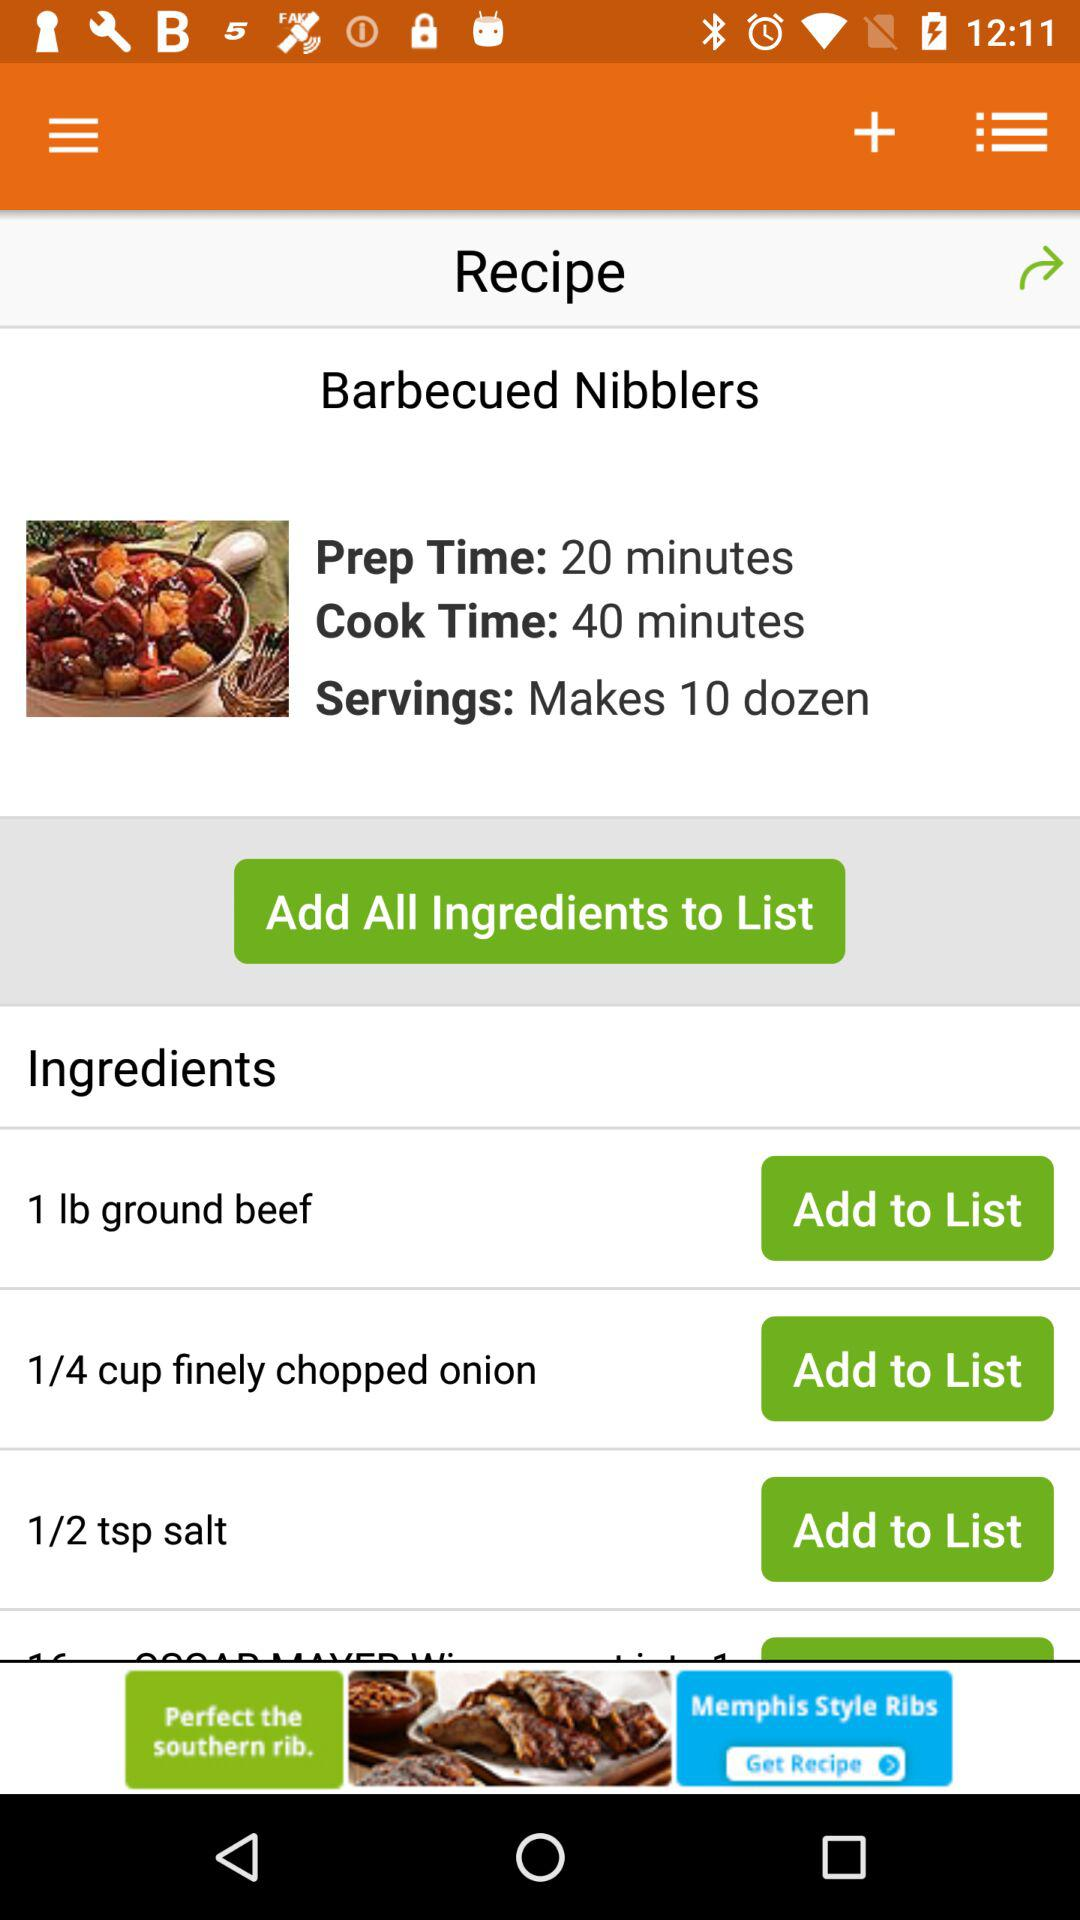How many more minutes does it take to cook than prep?
Answer the question using a single word or phrase. 20 